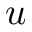Convert formula to latex. <formula><loc_0><loc_0><loc_500><loc_500>u</formula> 